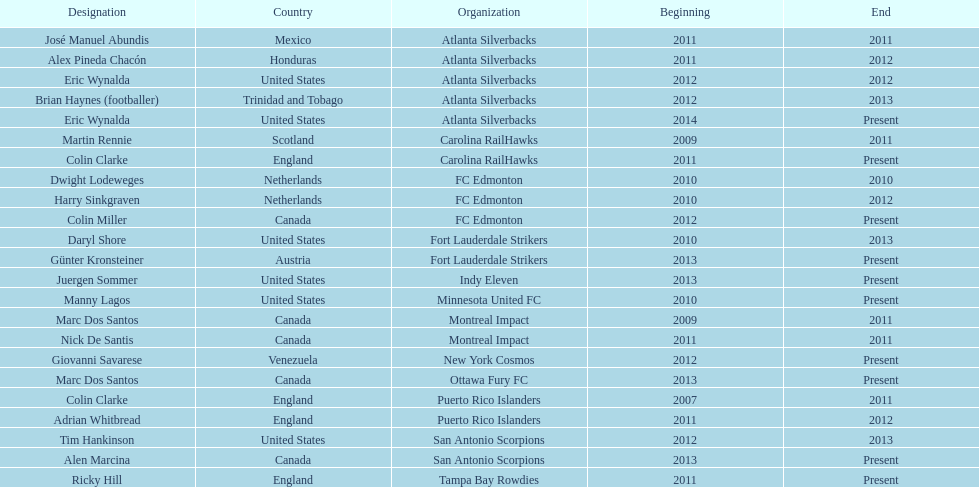What name is listed at the top? José Manuel Abundis. 